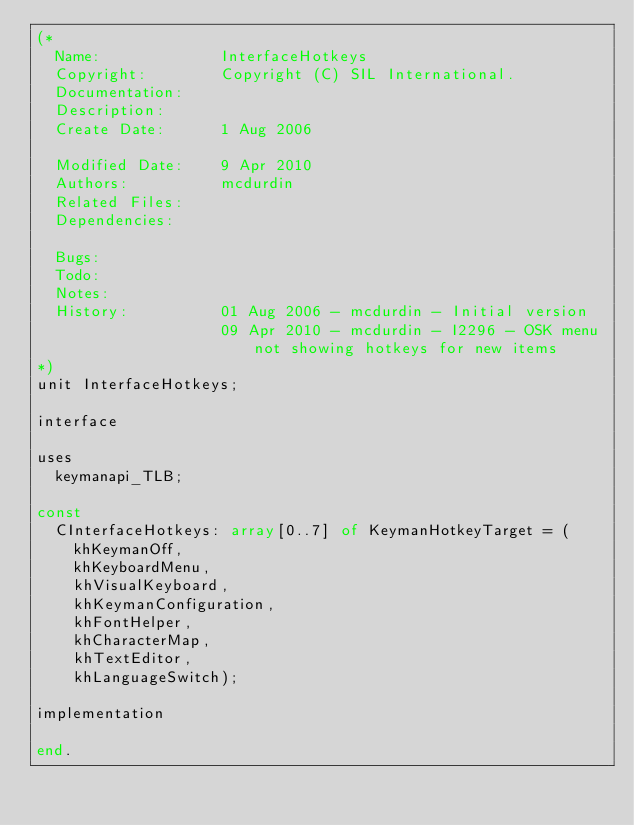Convert code to text. <code><loc_0><loc_0><loc_500><loc_500><_Pascal_>(*
  Name:             InterfaceHotkeys
  Copyright:        Copyright (C) SIL International.
  Documentation:    
  Description:      
  Create Date:      1 Aug 2006

  Modified Date:    9 Apr 2010
  Authors:          mcdurdin
  Related Files:    
  Dependencies:     

  Bugs:             
  Todo:             
  Notes:            
  History:          01 Aug 2006 - mcdurdin - Initial version
                    09 Apr 2010 - mcdurdin - I2296 - OSK menu not showing hotkeys for new items
*)
unit InterfaceHotkeys;

interface

uses
  keymanapi_TLB;

const
  CInterfaceHotkeys: array[0..7] of KeymanHotkeyTarget = (
    khKeymanOff,
    khKeyboardMenu,
    khVisualKeyboard,
    khKeymanConfiguration,
    khFontHelper,
    khCharacterMap,
    khTextEditor,
    khLanguageSwitch);

implementation

end.
</code> 